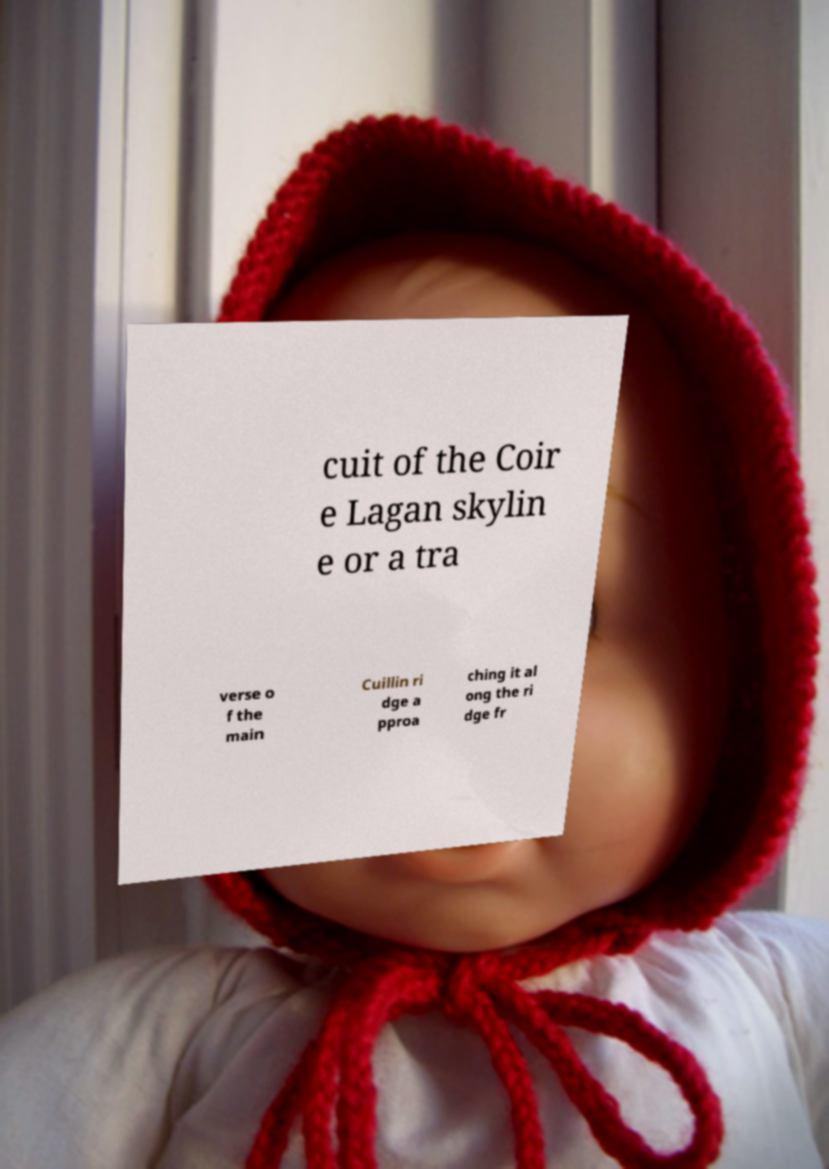I need the written content from this picture converted into text. Can you do that? cuit of the Coir e Lagan skylin e or a tra verse o f the main Cuillin ri dge a pproa ching it al ong the ri dge fr 